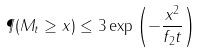<formula> <loc_0><loc_0><loc_500><loc_500>\P ( M _ { t } \geq x ) \leq 3 \exp \left ( - \frac { x ^ { 2 } } { f _ { 2 } t } \right )</formula> 